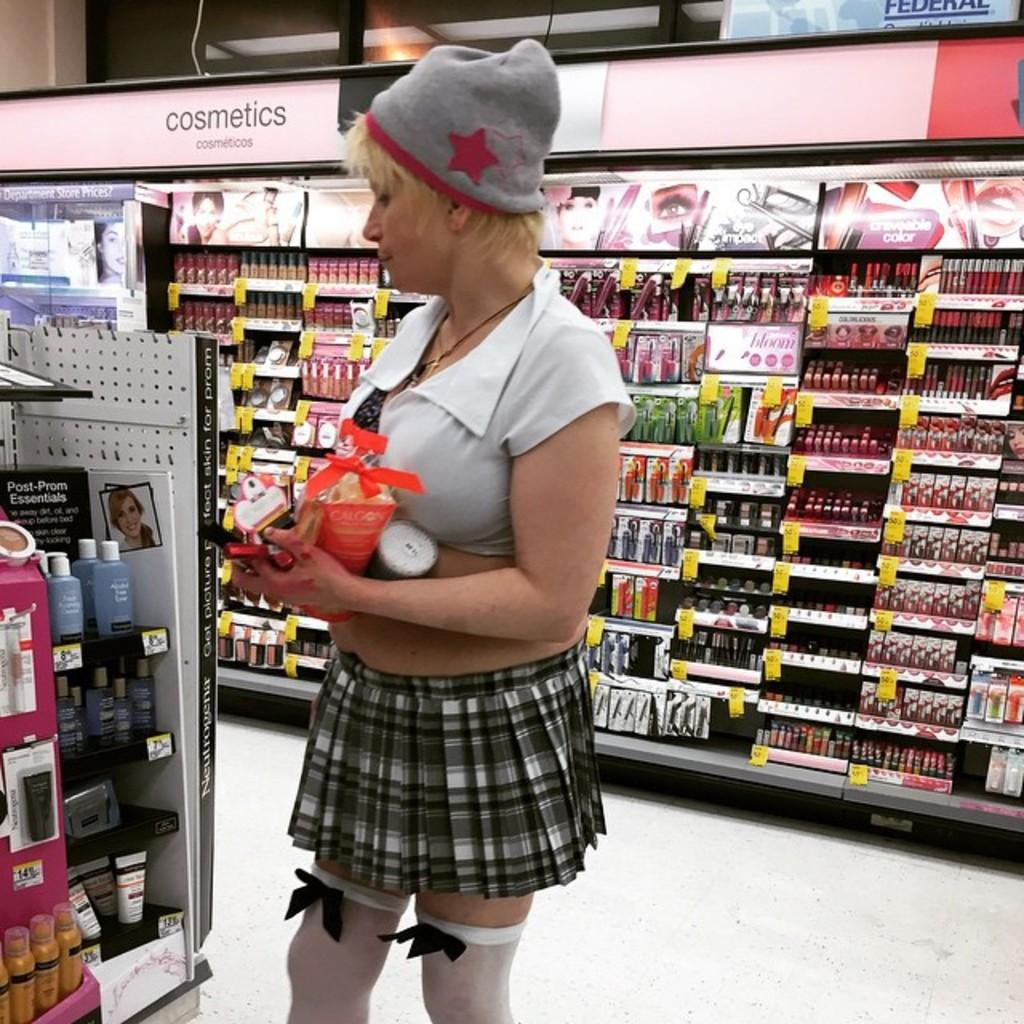What section of the store is this?
Offer a very short reply. Cosmetics. Can post-prom essentials be found here?
Your answer should be compact. Yes. 